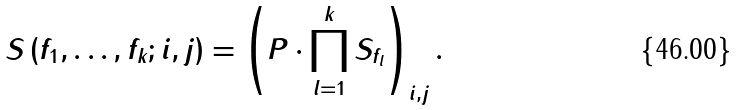<formula> <loc_0><loc_0><loc_500><loc_500>S \left ( f _ { 1 } , \dots , f _ { k } ; i , j \right ) = \left ( P \cdot \prod _ { l = 1 } ^ { k } S _ { f _ { l } } \right ) _ { i , j } .</formula> 